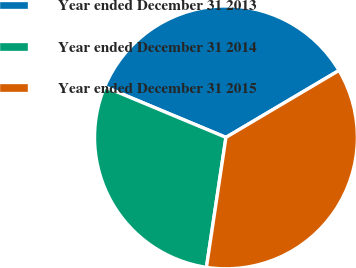<chart> <loc_0><loc_0><loc_500><loc_500><pie_chart><fcel>Year ended December 31 2013<fcel>Year ended December 31 2014<fcel>Year ended December 31 2015<nl><fcel>35.2%<fcel>28.92%<fcel>35.88%<nl></chart> 